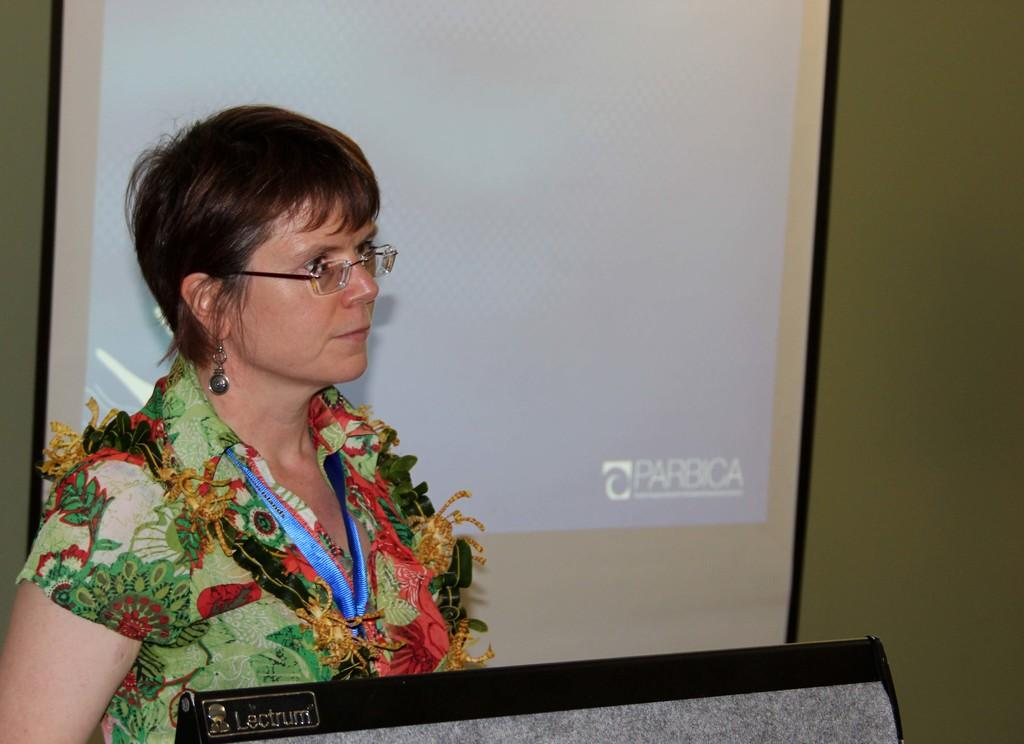Who is the main subject in the image? There is a woman in the image. What is the woman doing in the image? The woman is standing in front of a podium. In which direction is the woman looking? The woman is looking at the right side. What can be seen on the wall in the image? There is a screen visible in the image, and it is attached to a wall. What type of cloth is draped over the train in the image? There is no train present in the image, and therefore no cloth can be draped over it. 